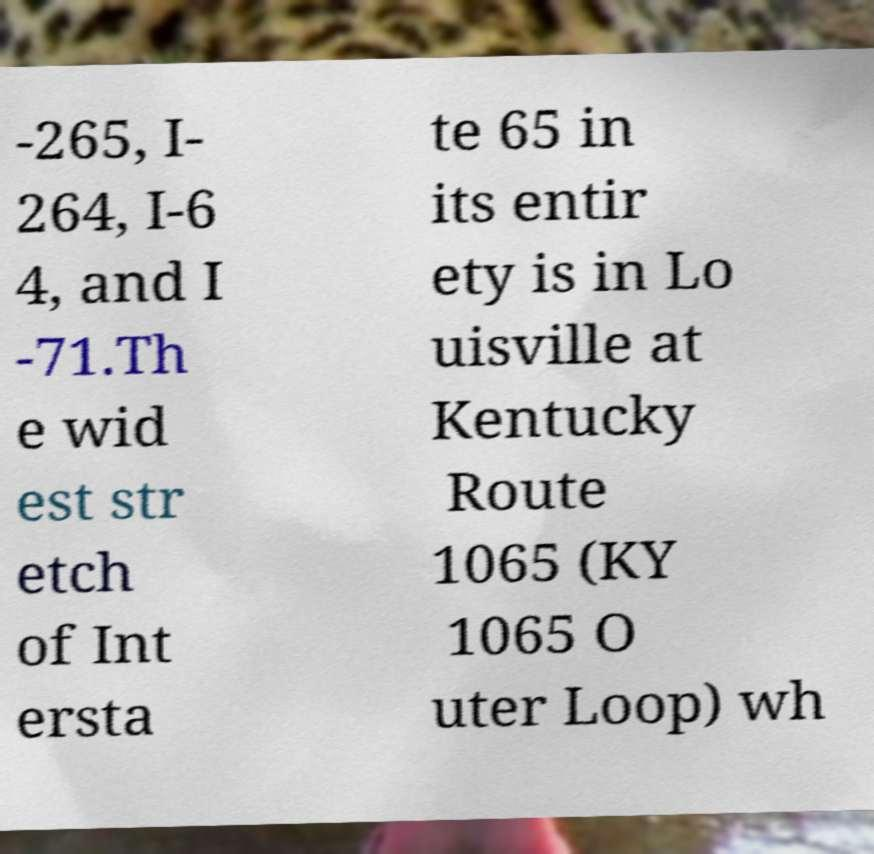Could you assist in decoding the text presented in this image and type it out clearly? -265, I- 264, I-6 4, and I -71.Th e wid est str etch of Int ersta te 65 in its entir ety is in Lo uisville at Kentucky Route 1065 (KY 1065 O uter Loop) wh 